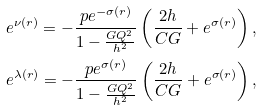<formula> <loc_0><loc_0><loc_500><loc_500>& e ^ { \nu ( r ) } = - \frac { p e ^ { - \sigma ( r ) } } { 1 - \frac { G Q ^ { 2 } } { h ^ { 2 } } } \left ( \frac { 2 h } { C G } + e ^ { \sigma ( r ) } \right ) , \\ & e ^ { \lambda ( r ) } = - \frac { p e ^ { \sigma ( r ) } } { 1 - \frac { G Q ^ { 2 } } { h ^ { 2 } } } \left ( \frac { 2 h } { C G } + e ^ { \sigma ( r ) } \right ) ,</formula> 